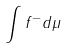Convert formula to latex. <formula><loc_0><loc_0><loc_500><loc_500>\int f ^ { - } d \mu</formula> 